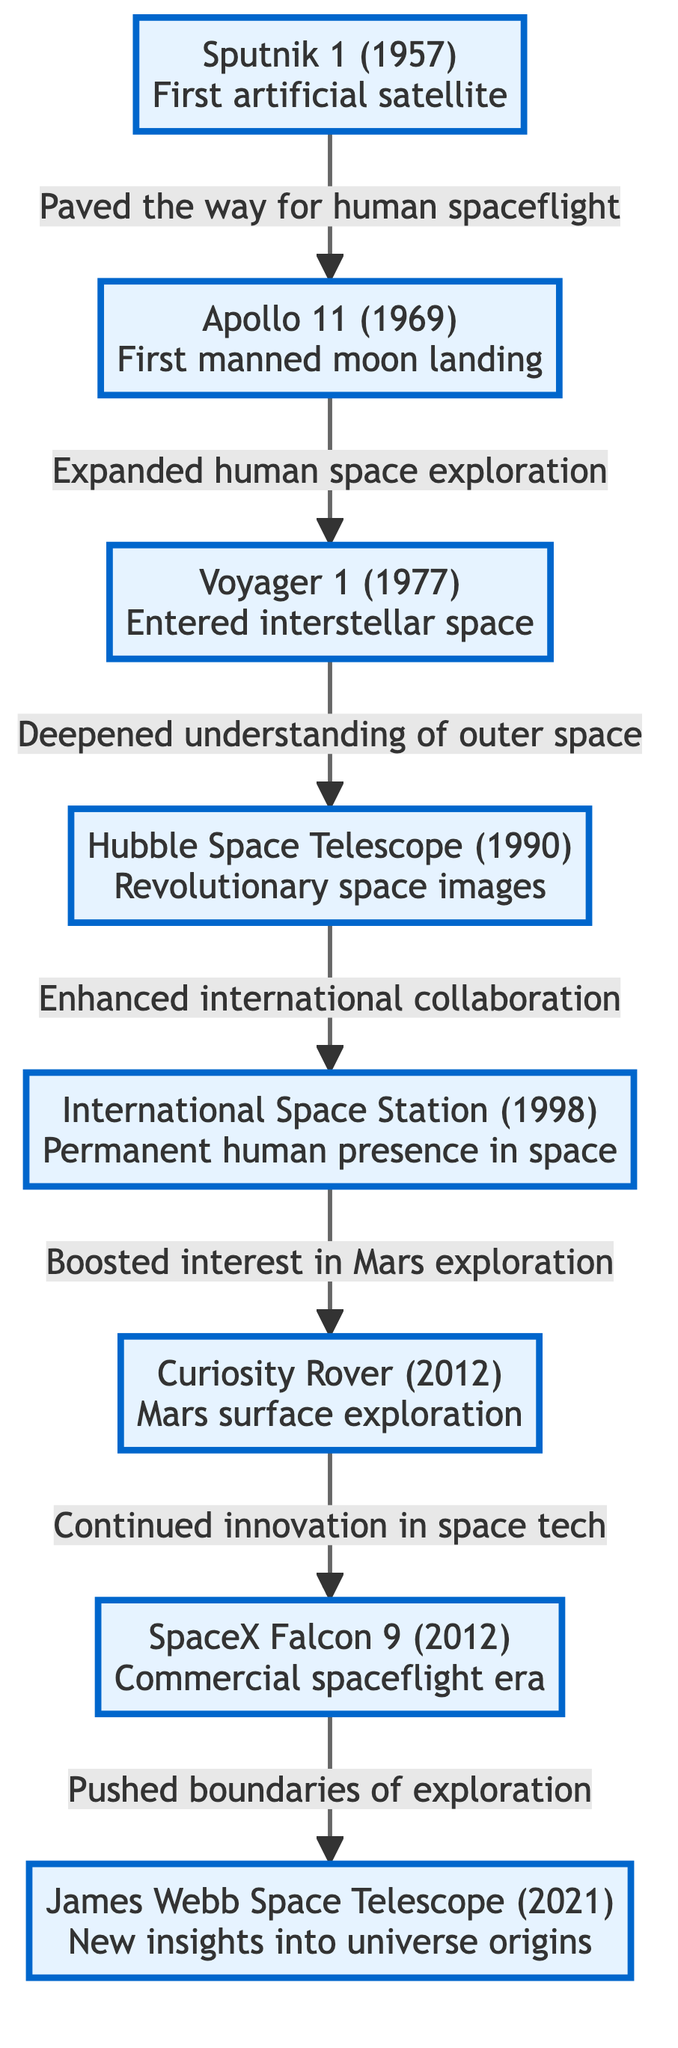What is the first milestone depicted in the diagram? The first milestone in the diagram is Sputnik 1, which is shown at the top. This can be determined by observing the arrangement of the nodes, where Sputnik 1 is the starting point with arrows leading to subsequent milestones.
Answer: Sputnik 1 How many total milestones are represented in the diagram? By counting all the distinct milestones listed in the diagram, there are a total of eight milestones, each represented by a separate node, leading to the conclusion of this count.
Answer: 8 What milestone is connected directly to the Apollo 11? The milestone directly connected to Apollo 11 is Voyager 1, as indicated by the arrow that flows from Apollo 11 to Voyager 1, illustrating the progression of milestones in space exploration.
Answer: Voyager 1 What is the relationship between the International Space Station and the Mars Rover? The relationship is that the International Space Station boosted interest in Mars exploration, as shown by the directed arrow pointing from the ISS node to the Mars Rover node, indicating a cause-effect relationship.
Answer: Boosted interest Which milestone represents the entry into interstellar space? The milestone representing the entry into interstellar space is Voyager 1, as mentioned in the description of that specific node, signifying its significant achievement.
Answer: Voyager 1 How did the Hubble Space Telescope contribute to human understanding of space? The Hubble Space Telescope enhanced international collaboration, as indicated by the arrow showing its connection to the International Space Station, where its contributions led to increased communication and cooperation among countries in space exploration.
Answer: Enhanced international collaboration What event immediately follows the Curiosity Rover in the diagram? The event that immediately follows the Curiosity Rover in the diagram is SpaceX Falcon 9, as there is a direct arrow leading from the Curiosity Rover node to the SpaceX node, indicating sequential milestones in space exploration.
Answer: SpaceX Falcon 9 Which milestone was achieved first in the 21st century? The first milestone achieved in the 21st century among those listed is the Curiosity Rover, which was launched in 2012; this can be identified by recognizing the chronological order of the events displayed in the diagram.
Answer: Curiosity Rover What does the James Webb Space Telescope provide insights into? The James Webb Space Telescope provides new insights into universe origins, as detailed in its description within the diagram, highlighting its scientific contributions to understanding fundamental cosmic questions.
Answer: Universe origins 